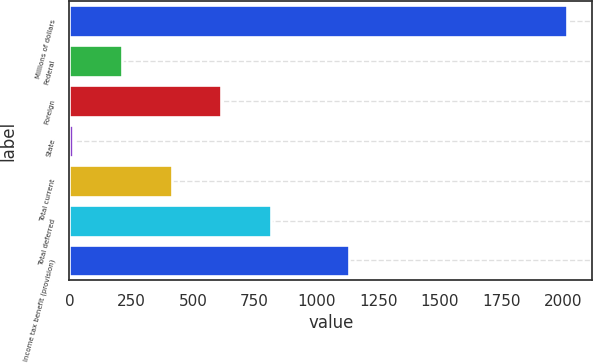<chart> <loc_0><loc_0><loc_500><loc_500><bar_chart><fcel>Millions of dollars<fcel>Federal<fcel>Foreign<fcel>State<fcel>Total current<fcel>Total deferred<fcel>Income tax benefit (provision)<nl><fcel>2017<fcel>214.3<fcel>614.9<fcel>14<fcel>414.6<fcel>815.2<fcel>1131<nl></chart> 